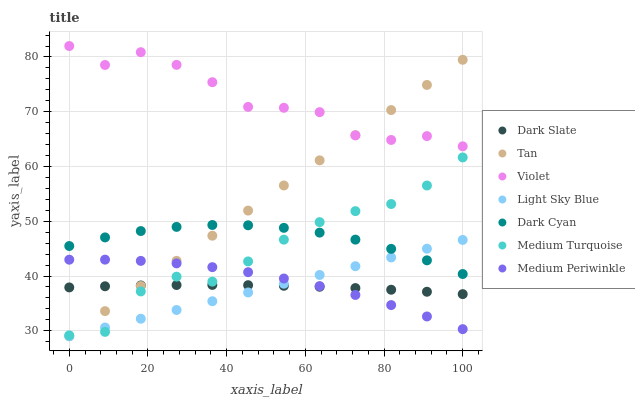Does Light Sky Blue have the minimum area under the curve?
Answer yes or no. Yes. Does Violet have the maximum area under the curve?
Answer yes or no. Yes. Does Dark Slate have the minimum area under the curve?
Answer yes or no. No. Does Dark Slate have the maximum area under the curve?
Answer yes or no. No. Is Light Sky Blue the smoothest?
Answer yes or no. Yes. Is Violet the roughest?
Answer yes or no. Yes. Is Dark Slate the smoothest?
Answer yes or no. No. Is Dark Slate the roughest?
Answer yes or no. No. Does Light Sky Blue have the lowest value?
Answer yes or no. Yes. Does Dark Slate have the lowest value?
Answer yes or no. No. Does Violet have the highest value?
Answer yes or no. Yes. Does Light Sky Blue have the highest value?
Answer yes or no. No. Is Dark Slate less than Violet?
Answer yes or no. Yes. Is Violet greater than Dark Slate?
Answer yes or no. Yes. Does Dark Slate intersect Medium Periwinkle?
Answer yes or no. Yes. Is Dark Slate less than Medium Periwinkle?
Answer yes or no. No. Is Dark Slate greater than Medium Periwinkle?
Answer yes or no. No. Does Dark Slate intersect Violet?
Answer yes or no. No. 